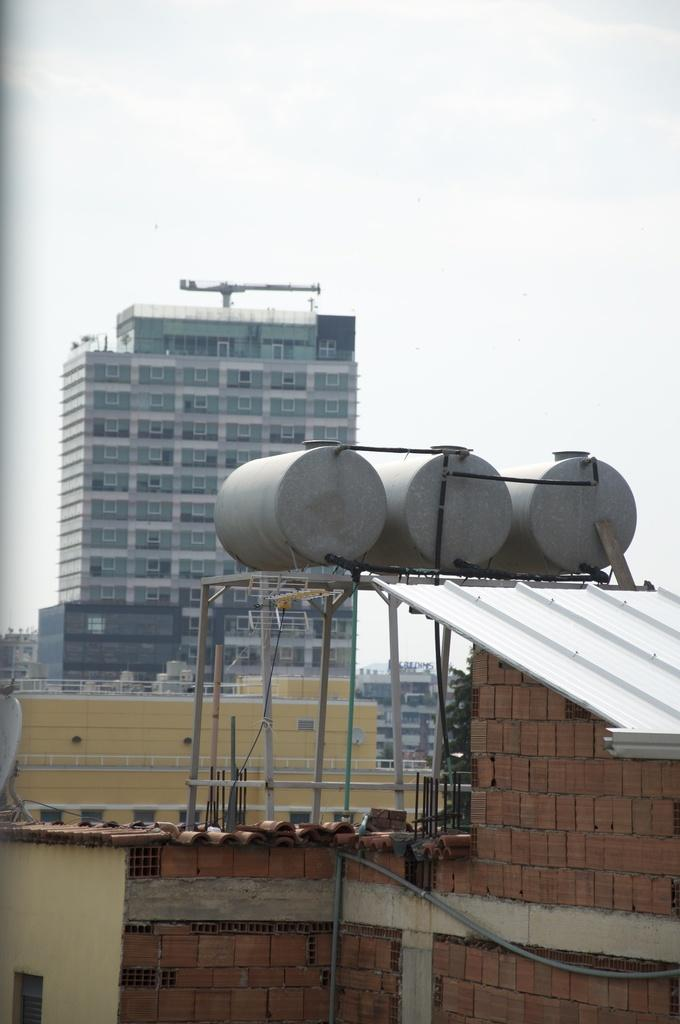What type of structures can be seen in the image? There are buildings in the image. What hobbies do the buildings in the image engage in? Buildings do not engage in hobbies, as they are inanimate structures. 